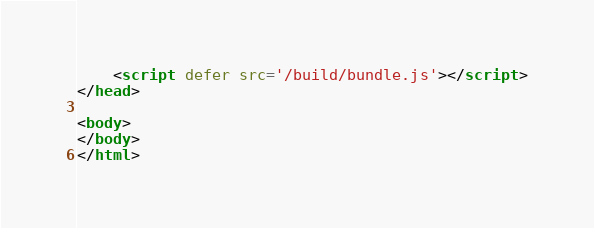Convert code to text. <code><loc_0><loc_0><loc_500><loc_500><_HTML_>
	<script defer src='/build/bundle.js'></script>
</head>

<body>
</body>
</html>
</code> 